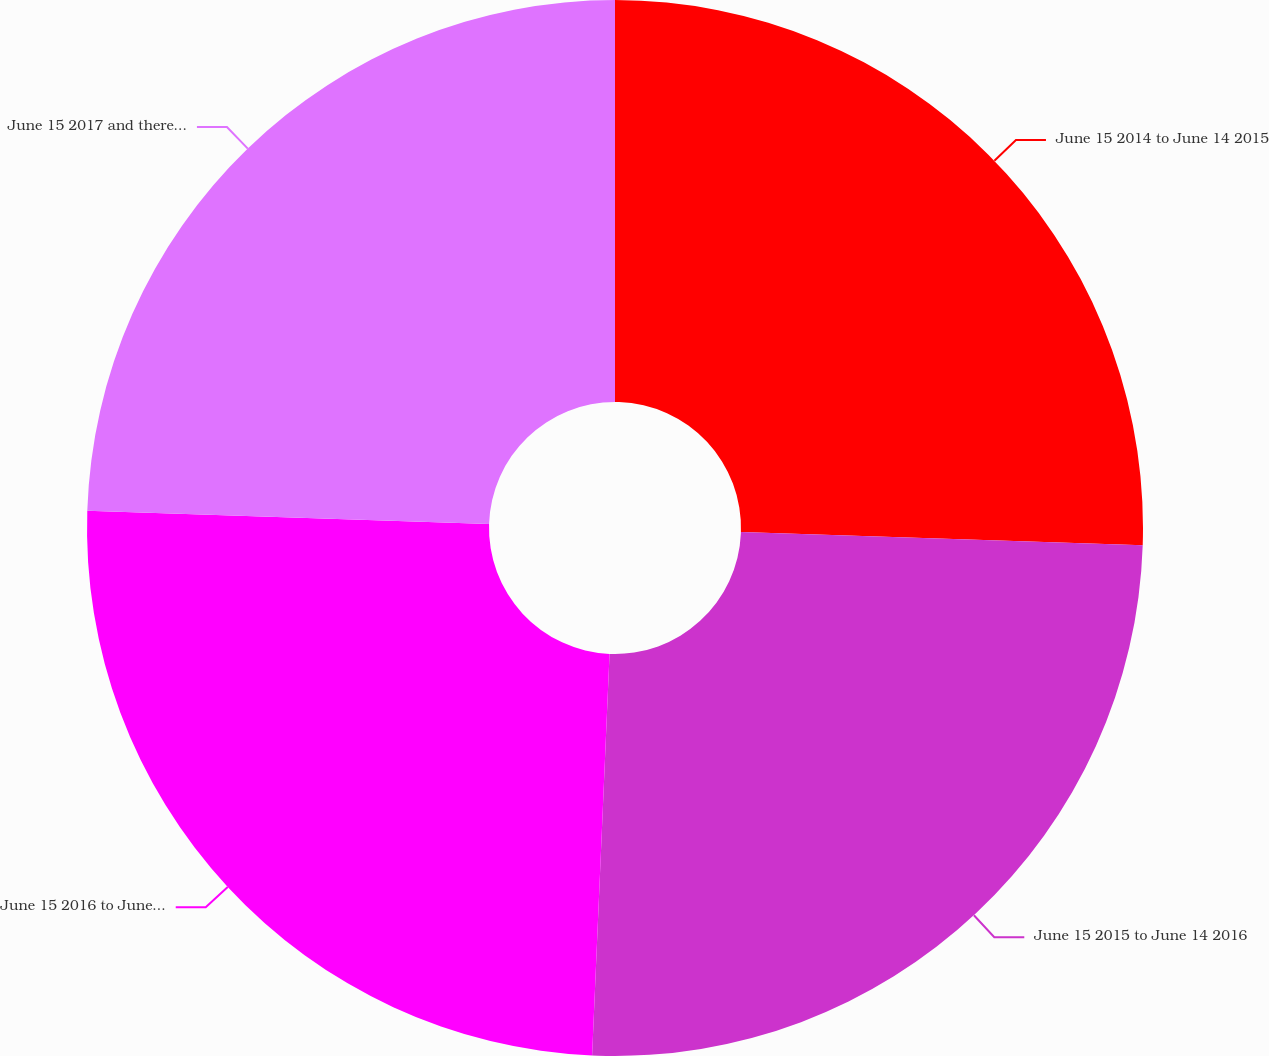Convert chart to OTSL. <chart><loc_0><loc_0><loc_500><loc_500><pie_chart><fcel>June 15 2014 to June 14 2015<fcel>June 15 2015 to June 14 2016<fcel>June 15 2016 to June 14 2017<fcel>June 15 2017 and thereafter<nl><fcel>25.52%<fcel>25.17%<fcel>24.83%<fcel>24.48%<nl></chart> 